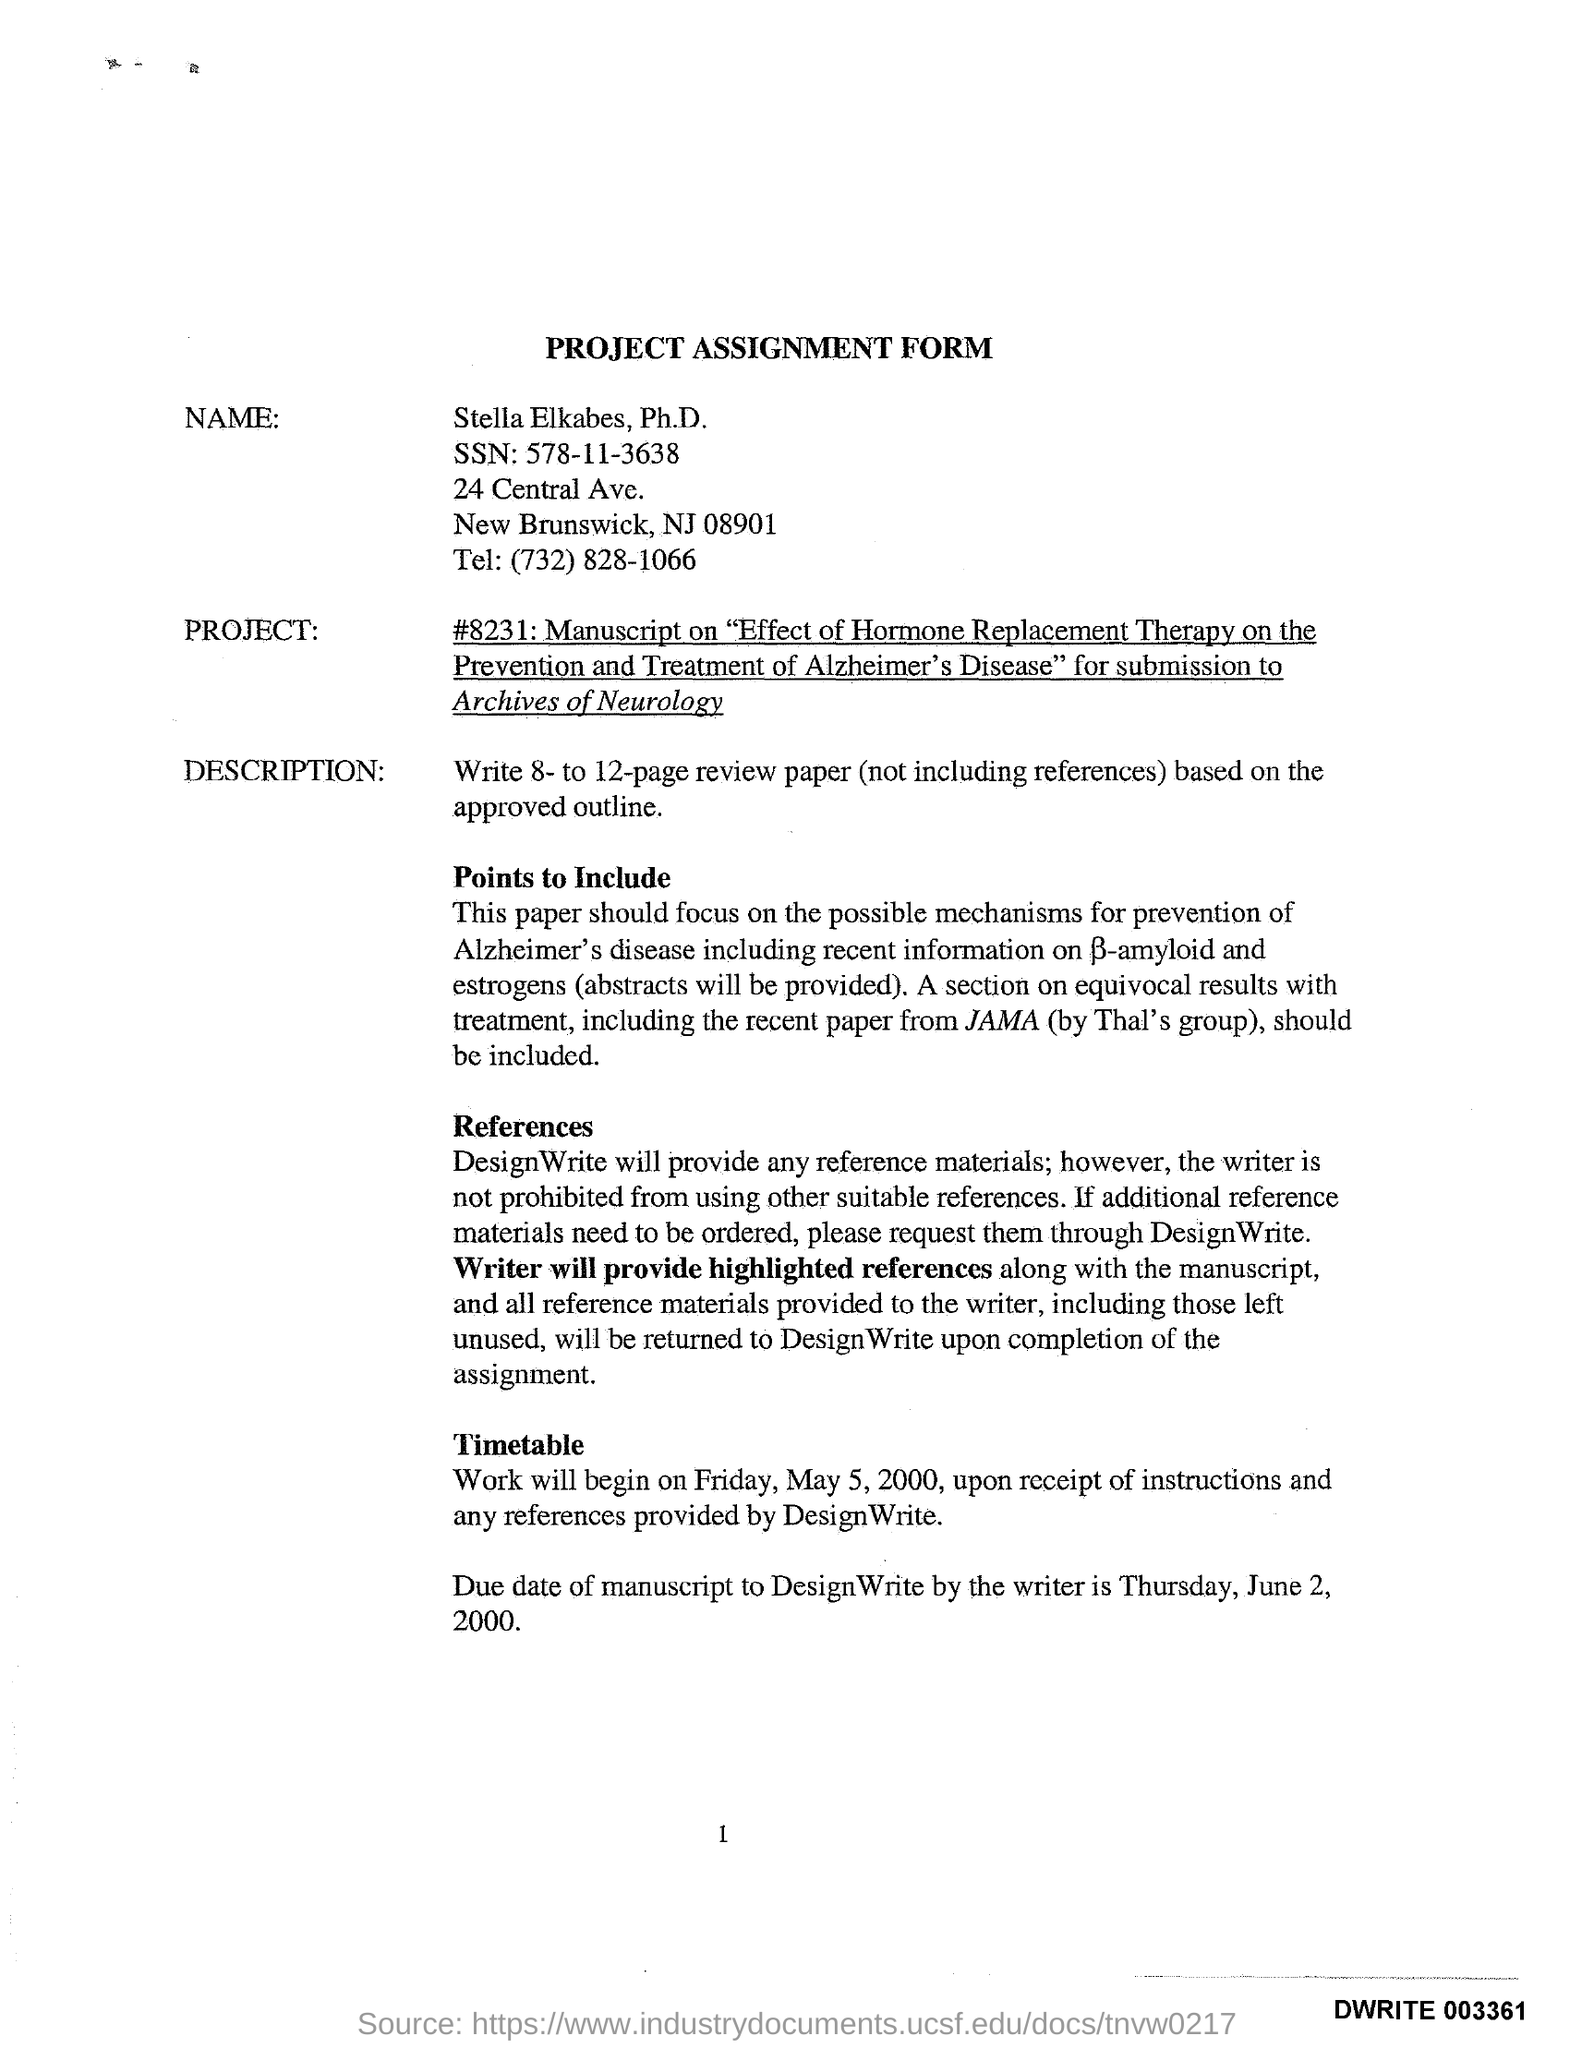What is the Heading of the Form?
Offer a terse response. Project Assignment Form. What is the Name on the Form?
Ensure brevity in your answer.  Stella Elkabes. What is the SSN?
Offer a terse response. 578-11-3638. What is the Tel.?
Offer a very short reply. (732) 828-1066. When will the work begin?
Your answer should be very brief. Friday, May 5, 2000. When is the Due date of manuscript to DesignWrite by the writer?
Offer a terse response. Thursday, June 2, 2000. 